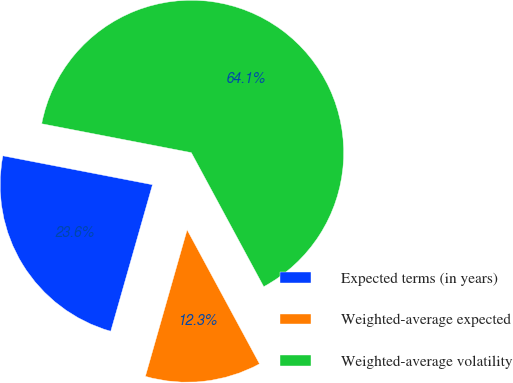<chart> <loc_0><loc_0><loc_500><loc_500><pie_chart><fcel>Expected terms (in years)<fcel>Weighted-average expected<fcel>Weighted-average volatility<nl><fcel>23.62%<fcel>12.3%<fcel>64.08%<nl></chart> 